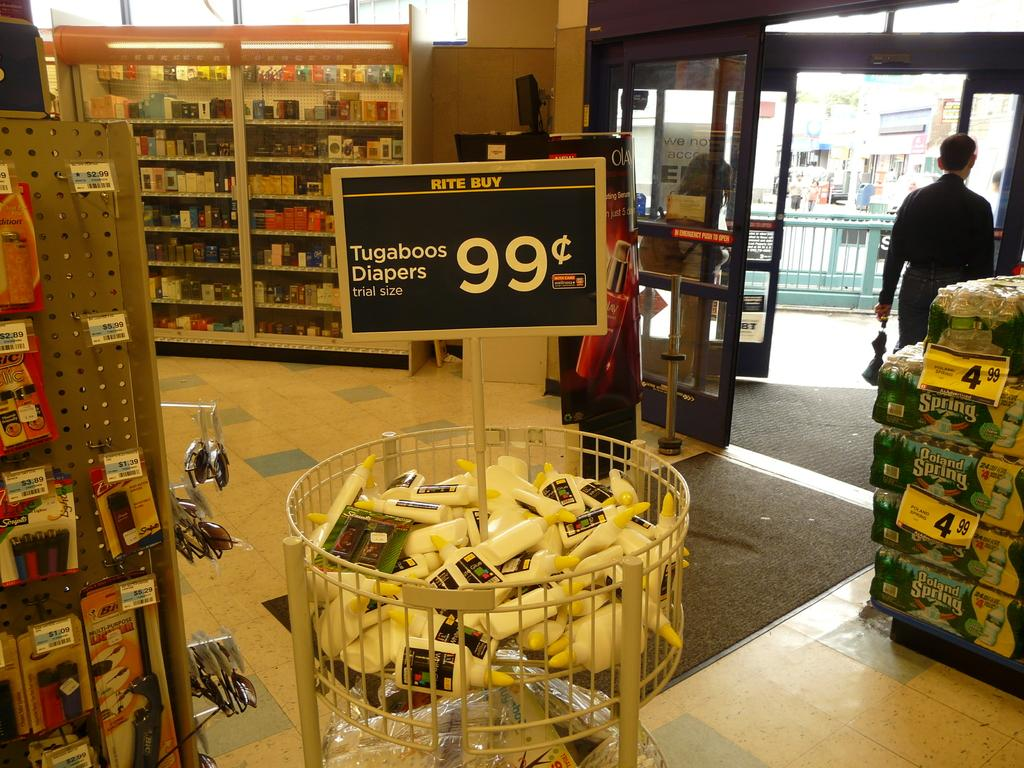<image>
Provide a brief description of the given image. Trial sizes of Tugaboos Diapers for sale for only 99 cents. 